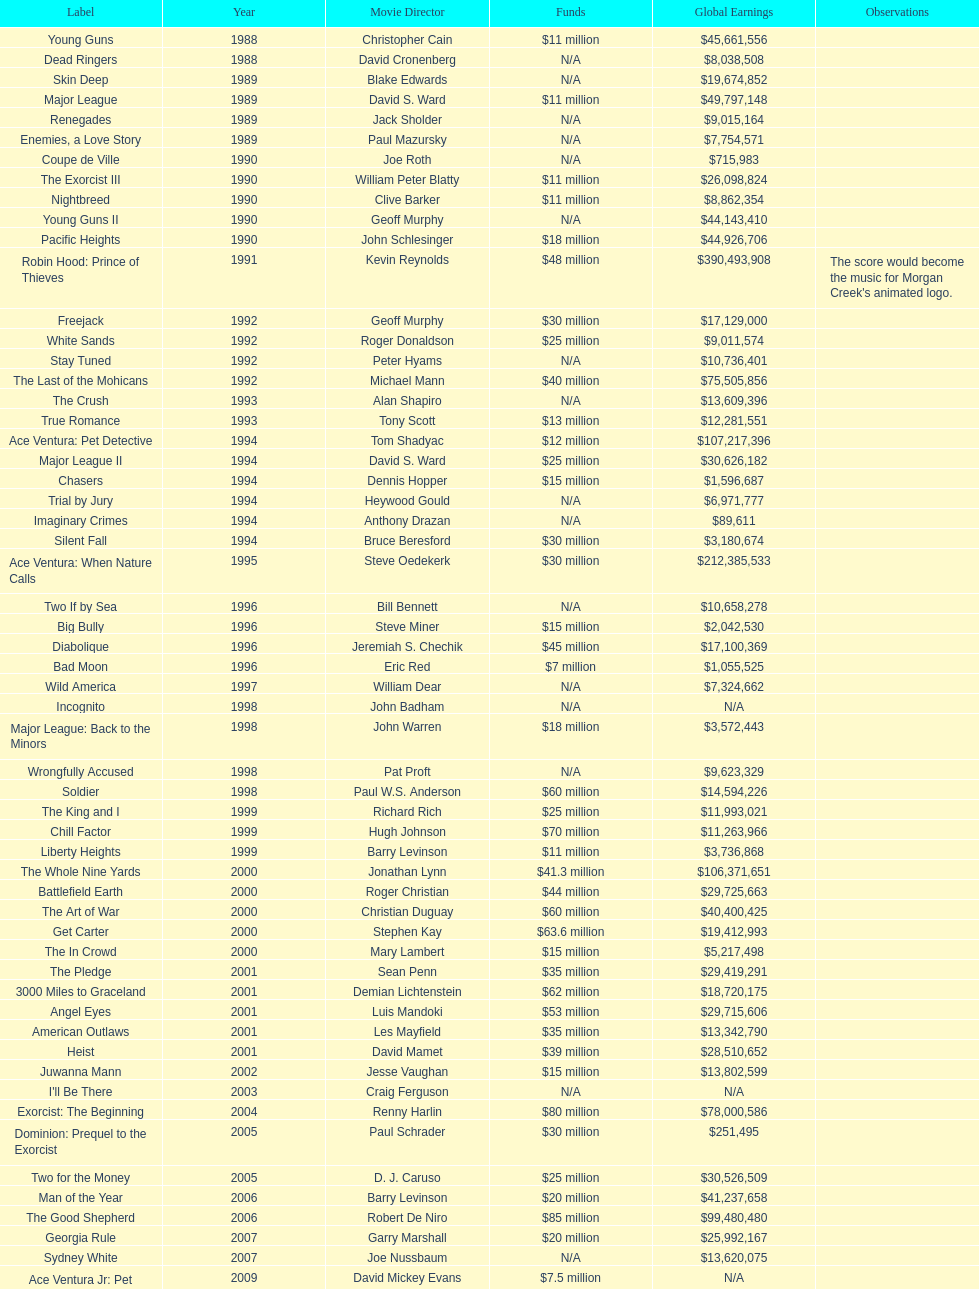What is the number of films directed by david s. ward? 2. 